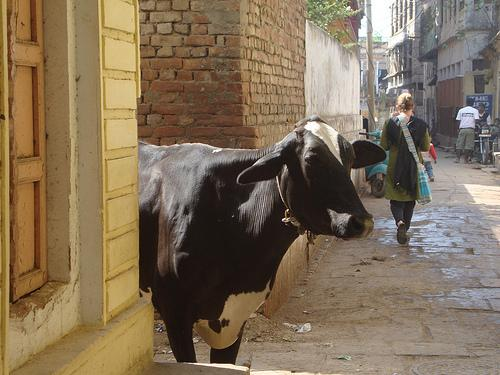Summarize the primary components of the image, and denote any relevant actions or persons. The image captures a curious black and white cow extending its head into an alley, with a walking woman and a man in shorts standing nearby. Concisely describe the main scene in the image including any significant details. The image shows a black and white cow with its head in an alley, with a woman walking by and a man standing nearby, both dressed casually. Write a concise description of the image, mentioning the key focus and what is happening around it. The image displays a black and white cow in an alley with its head sticking out, as a woman walks by and a man stands nearby in shorts. Choose the central object in the image and describe it and its environment in a couple of sentences. The image features a black and white cow sticking its head into an alleyway. Nearby, there is a woman walking and a man wearing shorts standing. Provide a brief summary of the main focus in the image and the actions taking place. A black and white cow is standing with its head in an alley, while a lady is walking and a man stands, both wearing shorts. Briefly depict the primary subject of the photograph along with any relevant surroundings or individuals. A curious black and white cow puts its head into an alley scene that includes a walking woman and a casually dressed man standing. Enumerate the principal elements within the image and their actions. 3. Man - standing in alley, wearing shorts Explain the core subject matter of the image and any related actions or individuals. The image features a black and white cow sticking its head into an alley with a walking woman and a man dressed in shorts standing nearby. Narrate the main event in the image and include any significant details or subjects. In the image, a black and white cow curiously sticks its head in an alley where a woman walks past and a casually dressed man stands. Mention the key subject in the photograph and indicate what is occurring around them. A black and white cow is the centerpiece of the image, as it pokes its head into the alley where a woman walks and a man stands in shorts. 